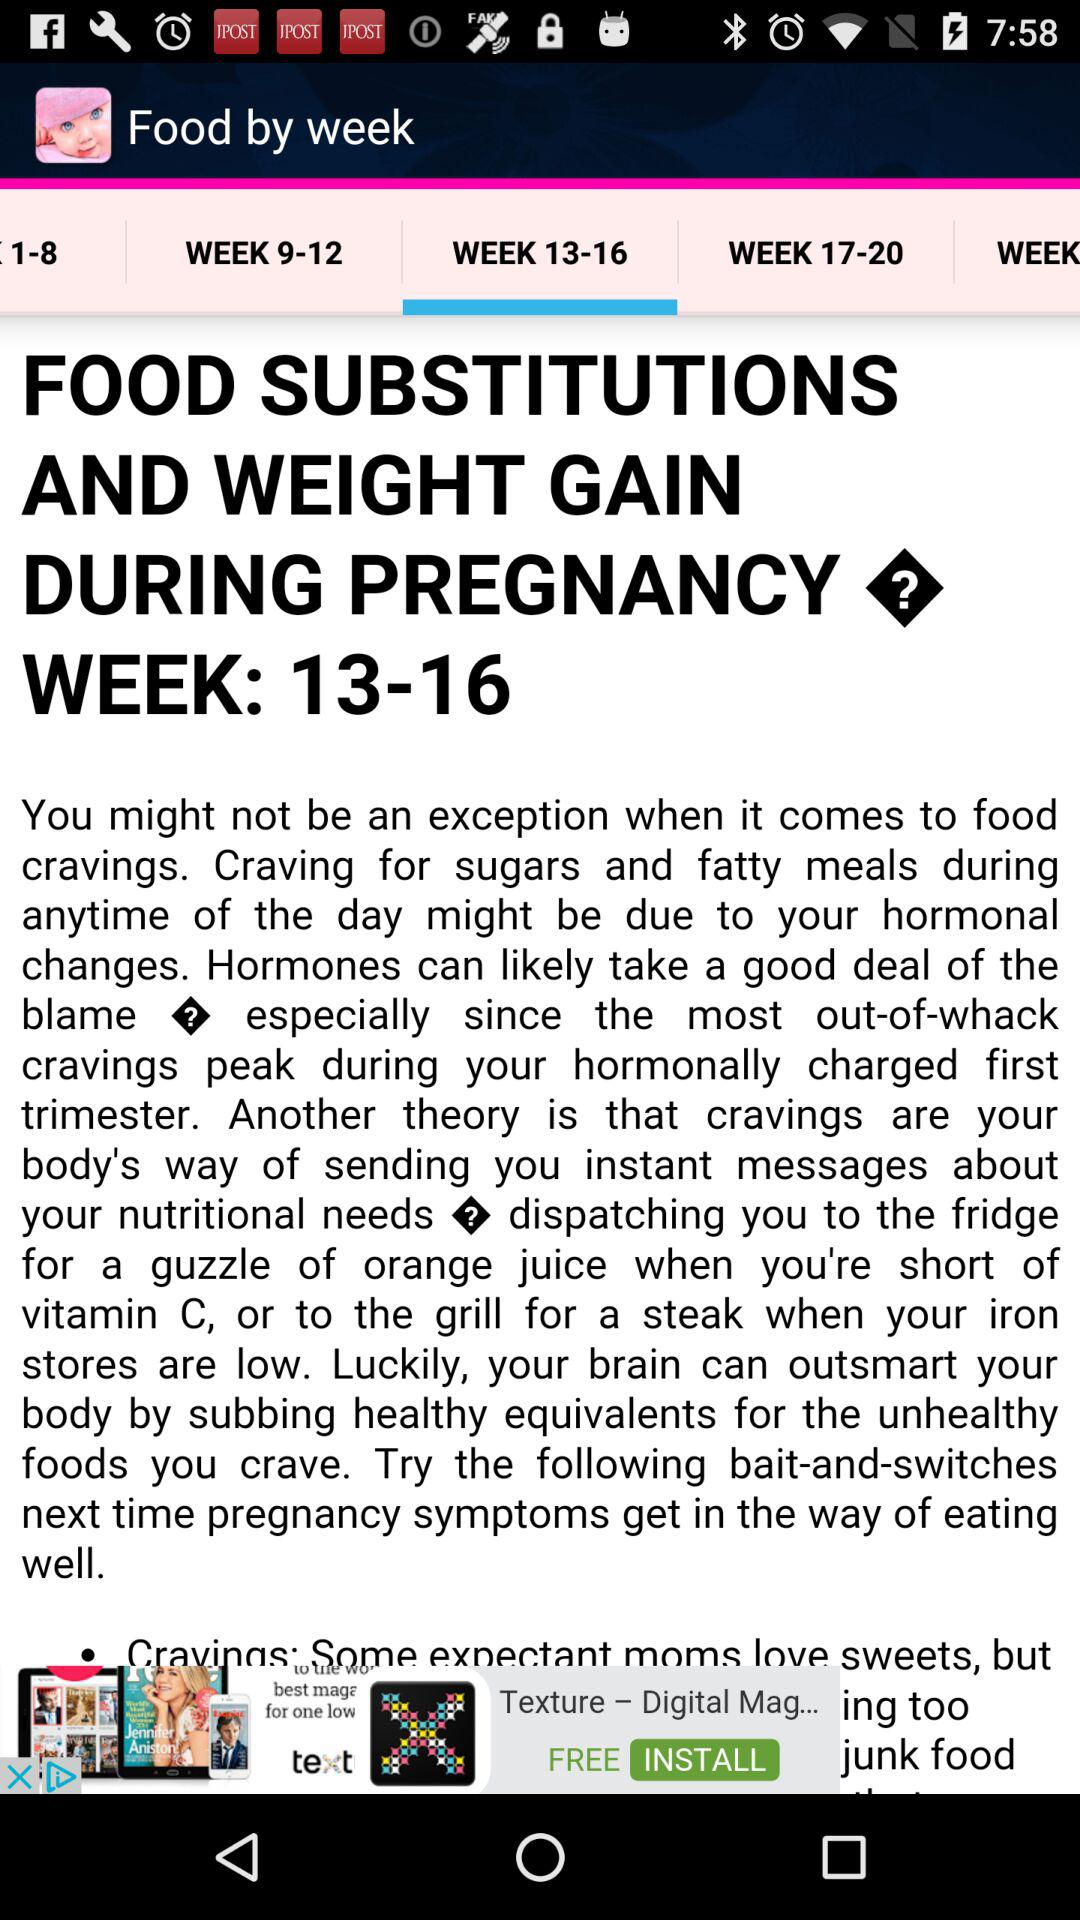Which tab has been selected in "Food by week"? The tab that has been selected in "Food by week" is "WEEK 13-16". 